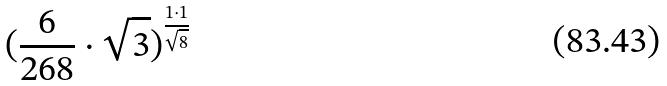Convert formula to latex. <formula><loc_0><loc_0><loc_500><loc_500>( \frac { 6 } { 2 6 8 } \cdot \sqrt { 3 } ) ^ { \frac { 1 \cdot 1 } { \sqrt { 8 } } }</formula> 